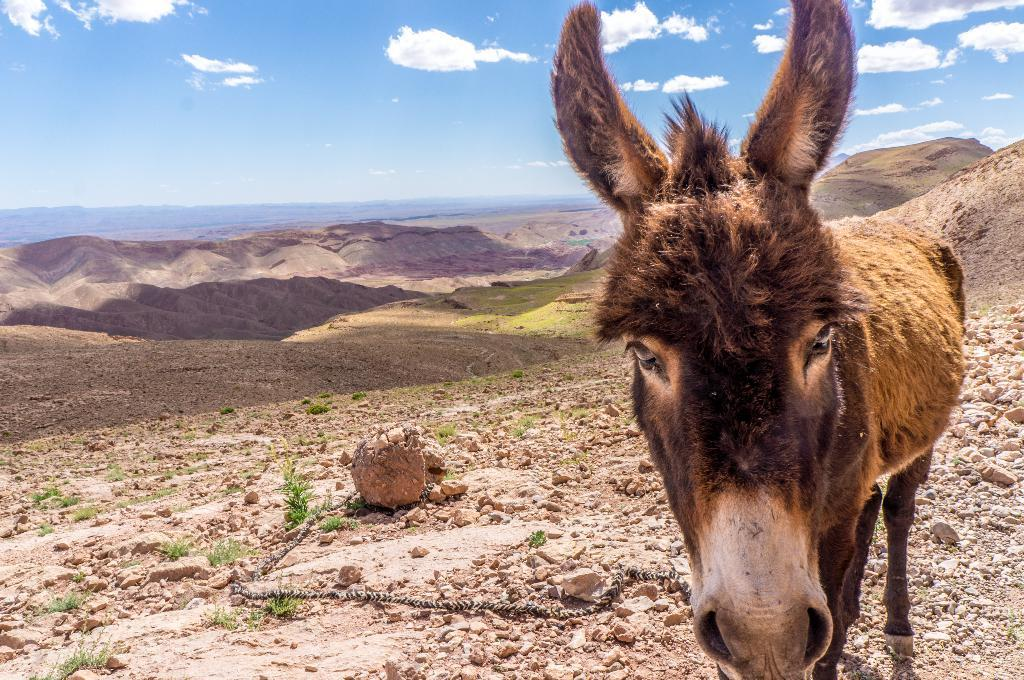What type of animal is in the image? There is a brown-colored donkey in the image. What is the donkey doing in the image? The donkey is standing. What can be seen on the ground in the image? There are stones and grass visible in the image. What is the donkey tied to in the image? There is a rope in the image, which the donkey is likely tied to. What is visible in the background of the image? There are clouds and the sky visible in the background of the image. What type of jewel is hanging from the donkey's neck in the image? There is no jewel present in the image; the donkey is tied with a rope. What type of thing is the donkey trying to diffuse in the image? There is no bomb or any object related to defusing in the image; it is a simple image of a donkey standing with a rope tied to it. 